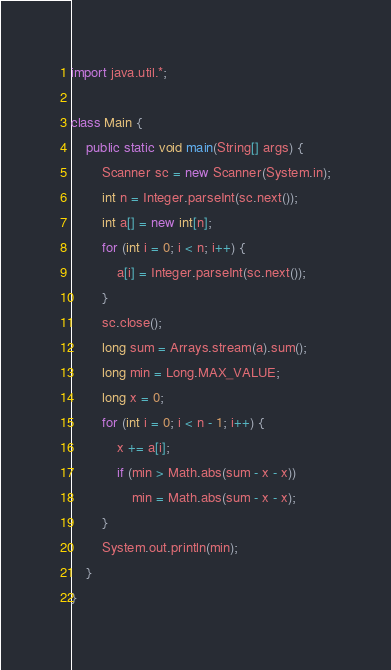<code> <loc_0><loc_0><loc_500><loc_500><_Java_>import java.util.*;

class Main {
    public static void main(String[] args) {
        Scanner sc = new Scanner(System.in);
        int n = Integer.parseInt(sc.next());
        int a[] = new int[n];
        for (int i = 0; i < n; i++) {
            a[i] = Integer.parseInt(sc.next());
        }
        sc.close();
        long sum = Arrays.stream(a).sum();
        long min = Long.MAX_VALUE;
        long x = 0;
        for (int i = 0; i < n - 1; i++) {
            x += a[i];
            if (min > Math.abs(sum - x - x))
                min = Math.abs(sum - x - x);
        }
        System.out.println(min);
    }
}</code> 